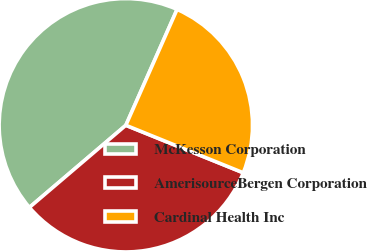<chart> <loc_0><loc_0><loc_500><loc_500><pie_chart><fcel>McKesson Corporation<fcel>AmerisourceBergen Corporation<fcel>Cardinal Health Inc<nl><fcel>42.86%<fcel>32.65%<fcel>24.49%<nl></chart> 